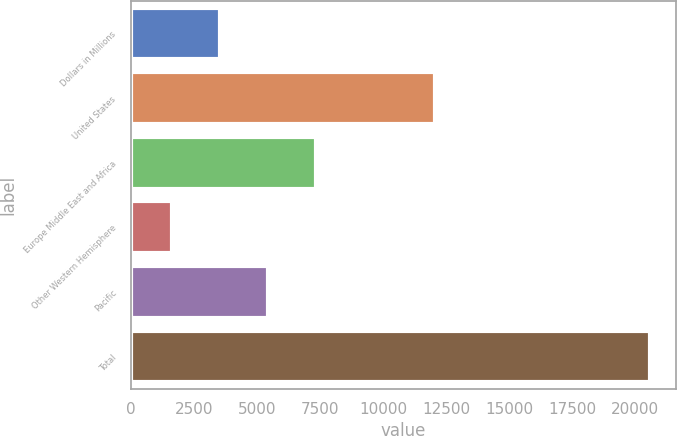<chart> <loc_0><loc_0><loc_500><loc_500><bar_chart><fcel>Dollars in Millions<fcel>United States<fcel>Europe Middle East and Africa<fcel>Other Western Hemisphere<fcel>Pacific<fcel>Total<nl><fcel>3519.5<fcel>12042<fcel>7314.5<fcel>1622<fcel>5417<fcel>20597<nl></chart> 